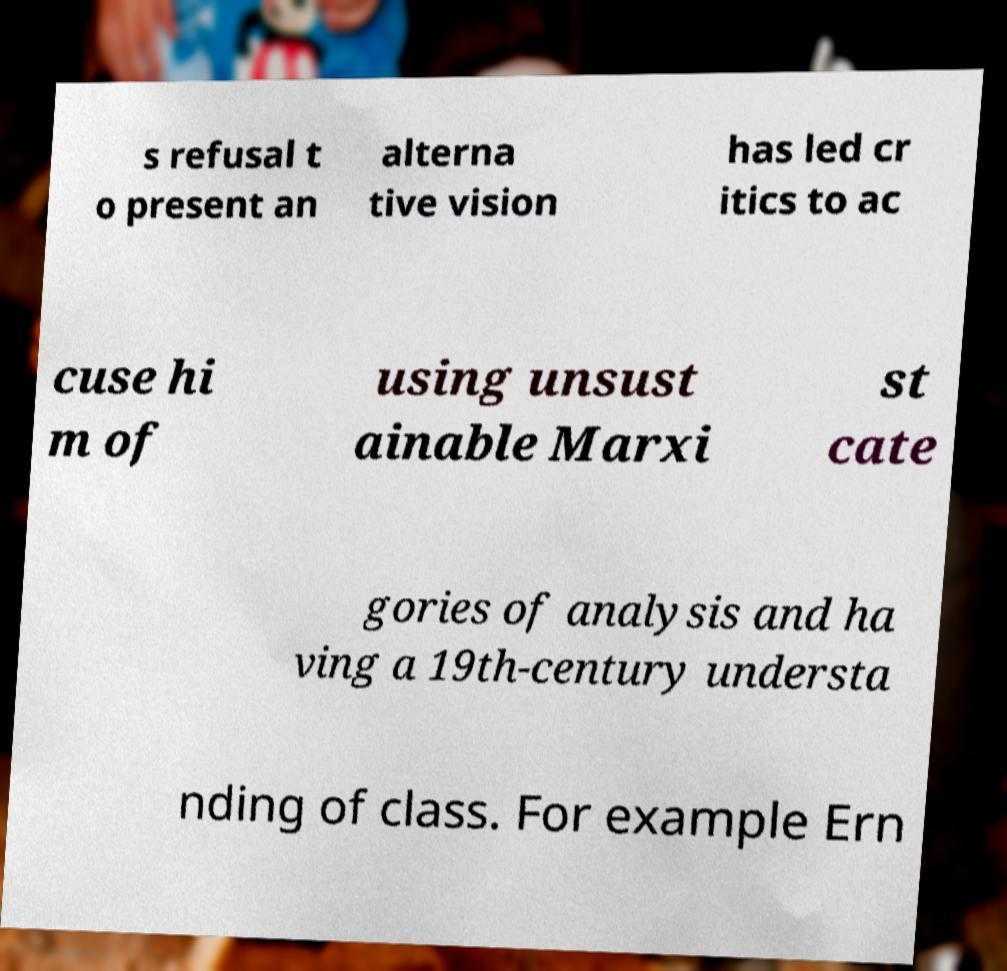Please read and relay the text visible in this image. What does it say? s refusal t o present an alterna tive vision has led cr itics to ac cuse hi m of using unsust ainable Marxi st cate gories of analysis and ha ving a 19th-century understa nding of class. For example Ern 